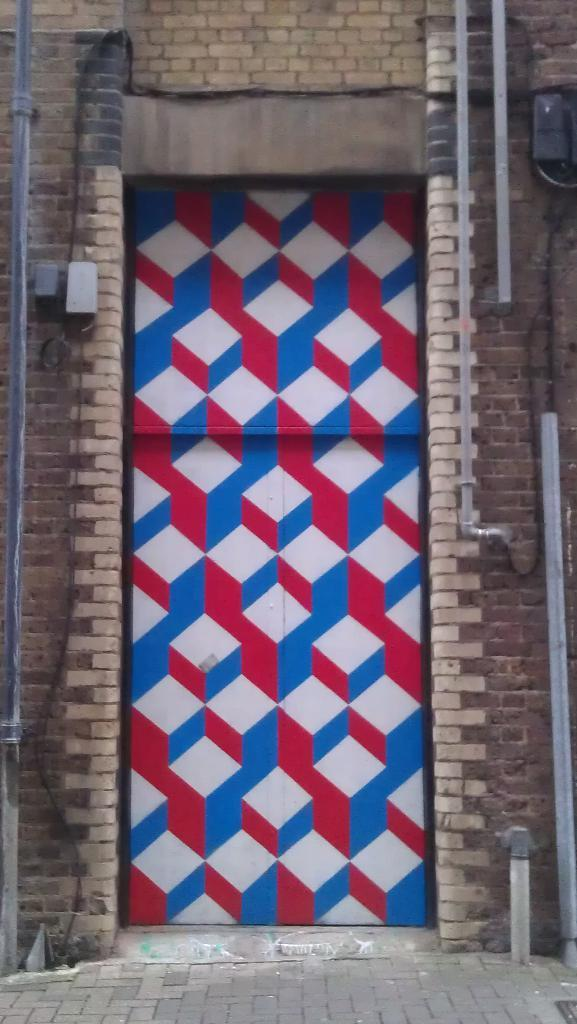What is the main subject in the center of the image? There is a closed door in the center of the image. What else can be seen in the image besides the closed door? Pipes are visible in the image. Are there any objects attached to the wall in the image? Yes, there are objects attached to the wall in the image. How many jellyfish are swimming in the image? There are no jellyfish present in the image. What type of division is taking place in the image? There is no division taking place in the image; it features a closed door, pipes, and objects attached to the wall. 